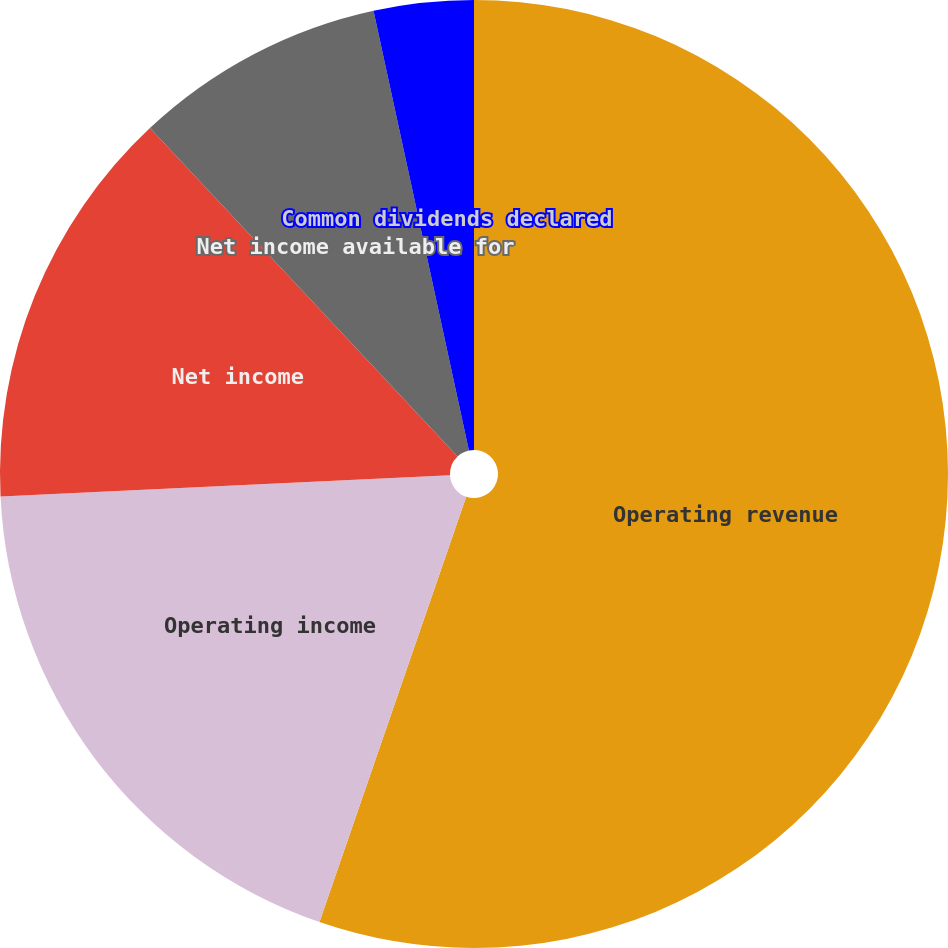Convert chart. <chart><loc_0><loc_0><loc_500><loc_500><pie_chart><fcel>Operating revenue<fcel>Operating income<fcel>Net income<fcel>Net income available for<fcel>Common dividends declared<nl><fcel>55.28%<fcel>18.96%<fcel>13.77%<fcel>8.58%<fcel>3.4%<nl></chart> 